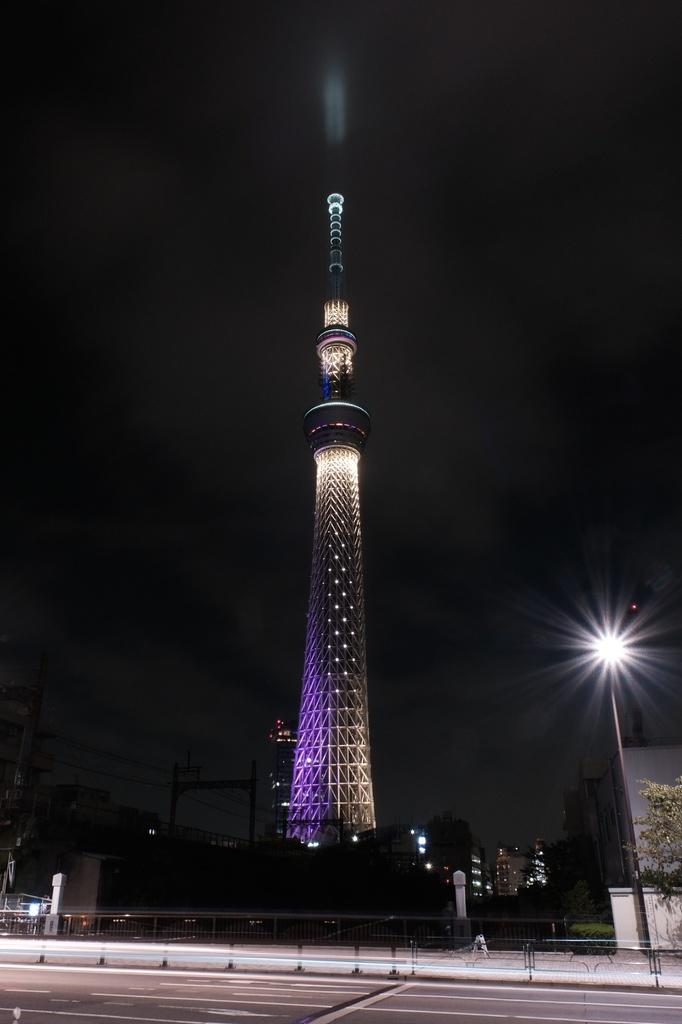What type of pathway is present in the image? There is a road in the image. What is located near the road? There is a railing near the road. What structure can be seen in the image? There is a tower in the image. What can be used for illumination in the image? There are lights visible in the image. What is visible in the background of the image? The sky is visible in the image. Who is the owner of the mask in the image? There is no mask present in the image, so it is not possible to determine the owner. 